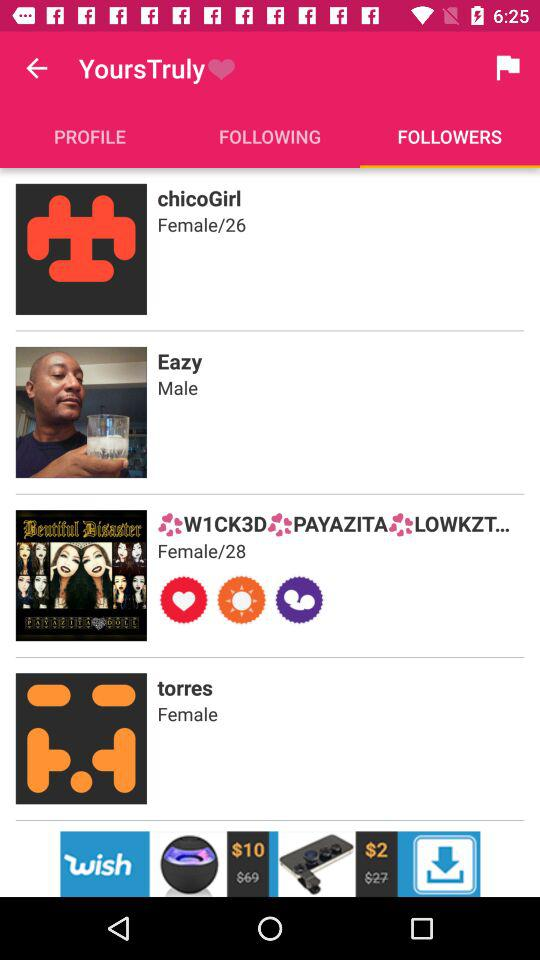What is the gender of Torres? The gender is female. 